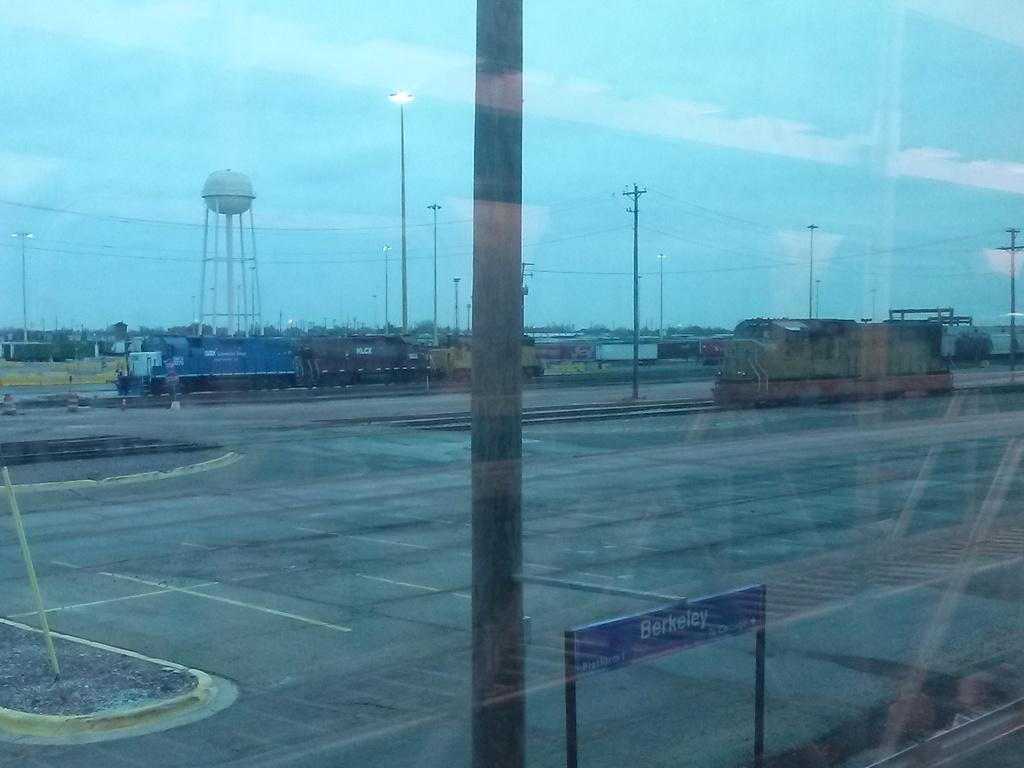<image>
Give a short and clear explanation of the subsequent image. A sign that says Berkeley stands near a field of train tracks. 